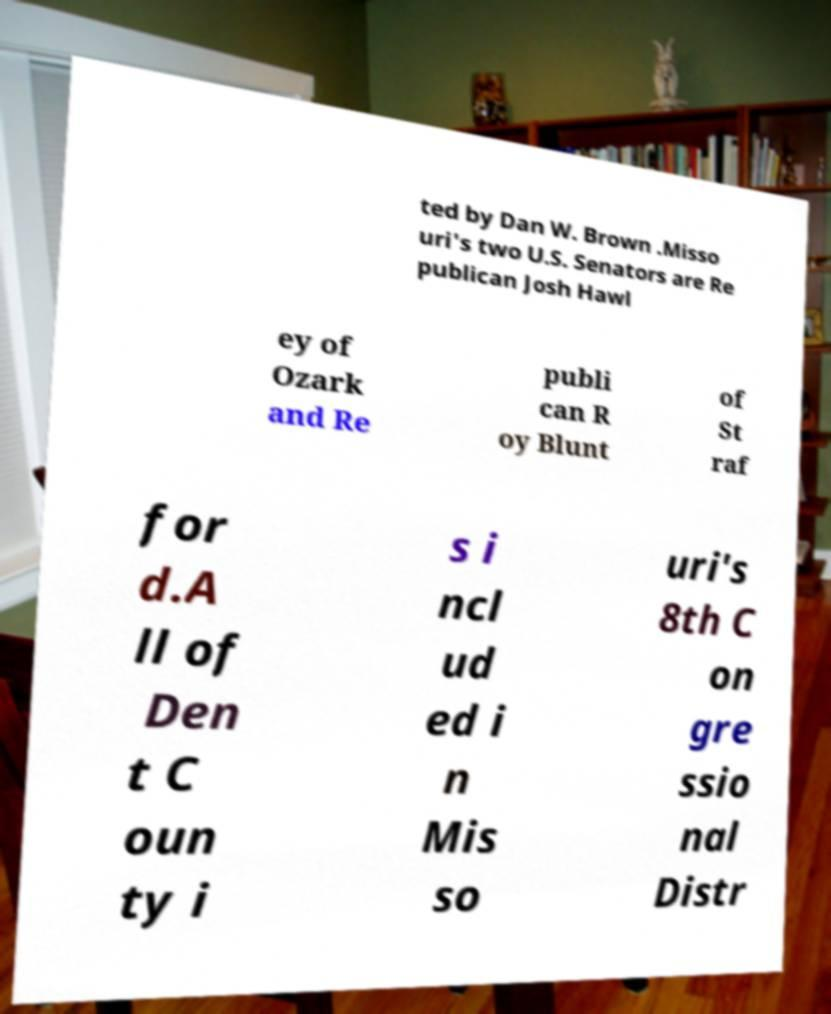Please identify and transcribe the text found in this image. ted by Dan W. Brown .Misso uri's two U.S. Senators are Re publican Josh Hawl ey of Ozark and Re publi can R oy Blunt of St raf for d.A ll of Den t C oun ty i s i ncl ud ed i n Mis so uri's 8th C on gre ssio nal Distr 